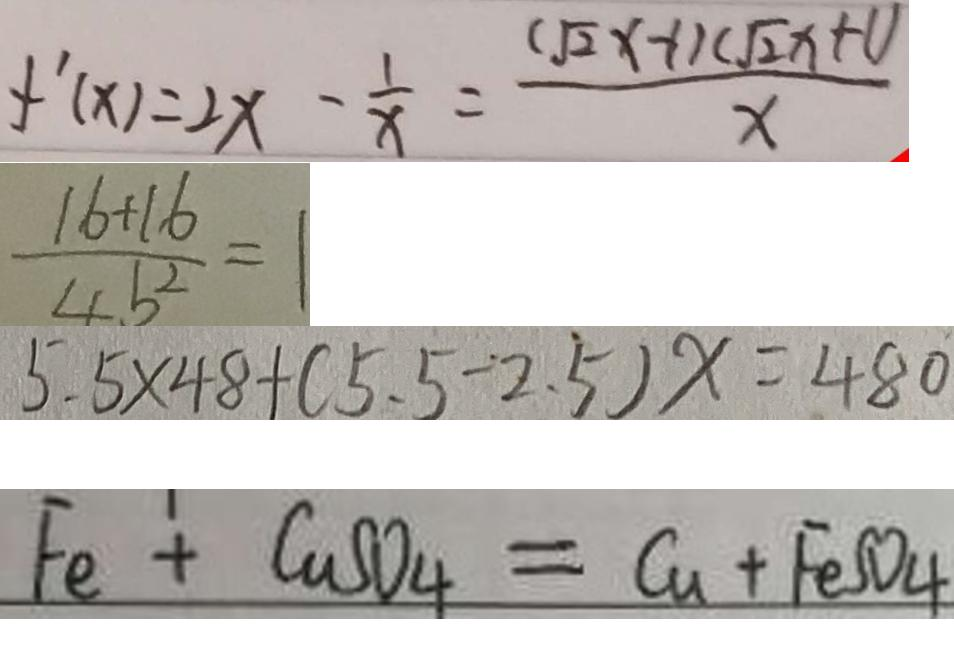Convert formula to latex. <formula><loc_0><loc_0><loc_500><loc_500>f ^ { \prime } ( x ) = 2 x - \frac { 1 } { x } = \frac { ( \sqrt { 2 } x - 1 ) ( \sqrt { 2 } x + 1 ) } { x } 
 \frac { 1 6 + 1 6 } { 4 b ^ { 2 } } = 1 
 5 . 5 \times 4 8 + ( 5 . 5 - 2 . 5 ) x = 4 8 0 
 F e + C u S O _ { 4 } = C u + F e S O _ { 4 }</formula> 